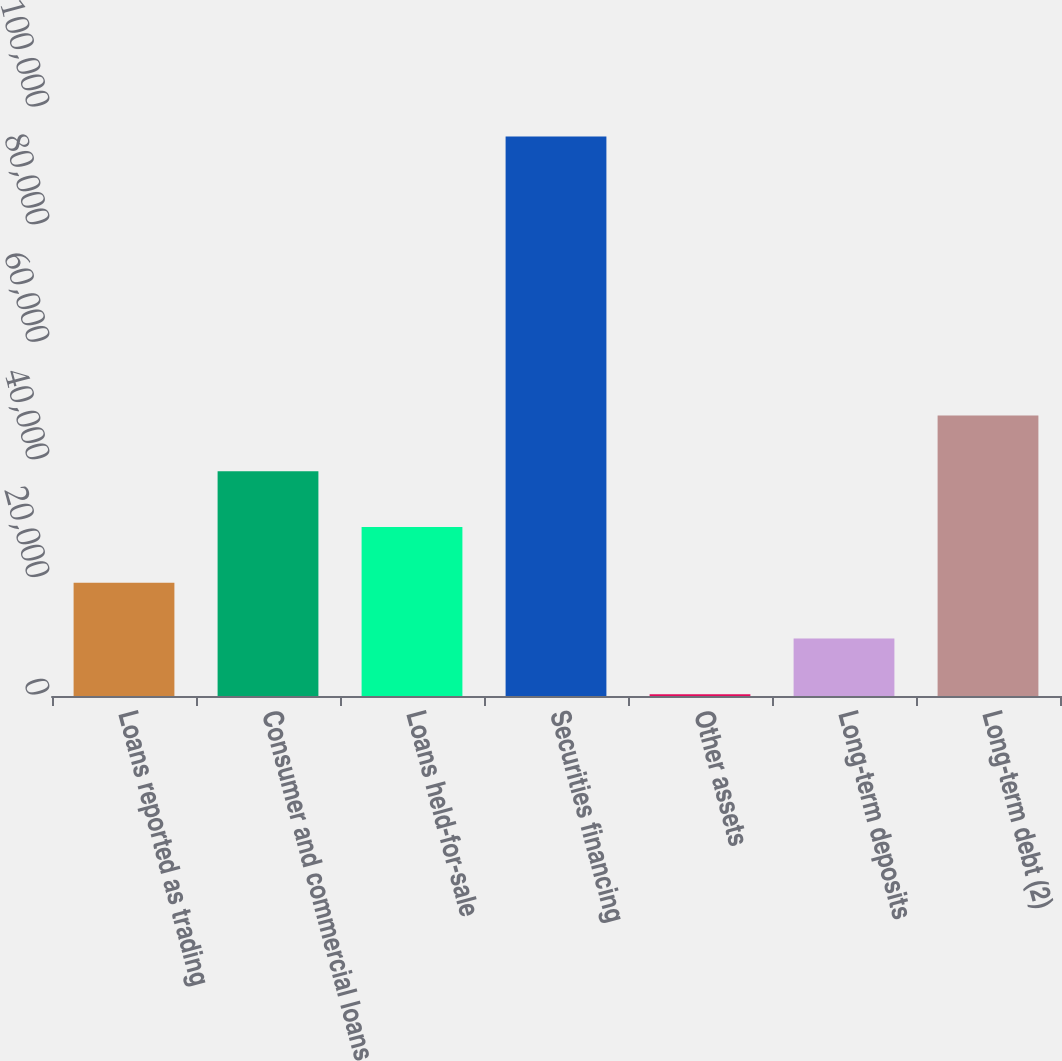Convert chart to OTSL. <chart><loc_0><loc_0><loc_500><loc_500><bar_chart><fcel>Loans reported as trading<fcel>Consumer and commercial loans<fcel>Loans held-for-sale<fcel>Securities financing<fcel>Other assets<fcel>Long-term deposits<fcel>Long-term debt (2)<nl><fcel>19253.6<fcel>38229.2<fcel>28741.4<fcel>95156<fcel>278<fcel>9765.8<fcel>47717<nl></chart> 